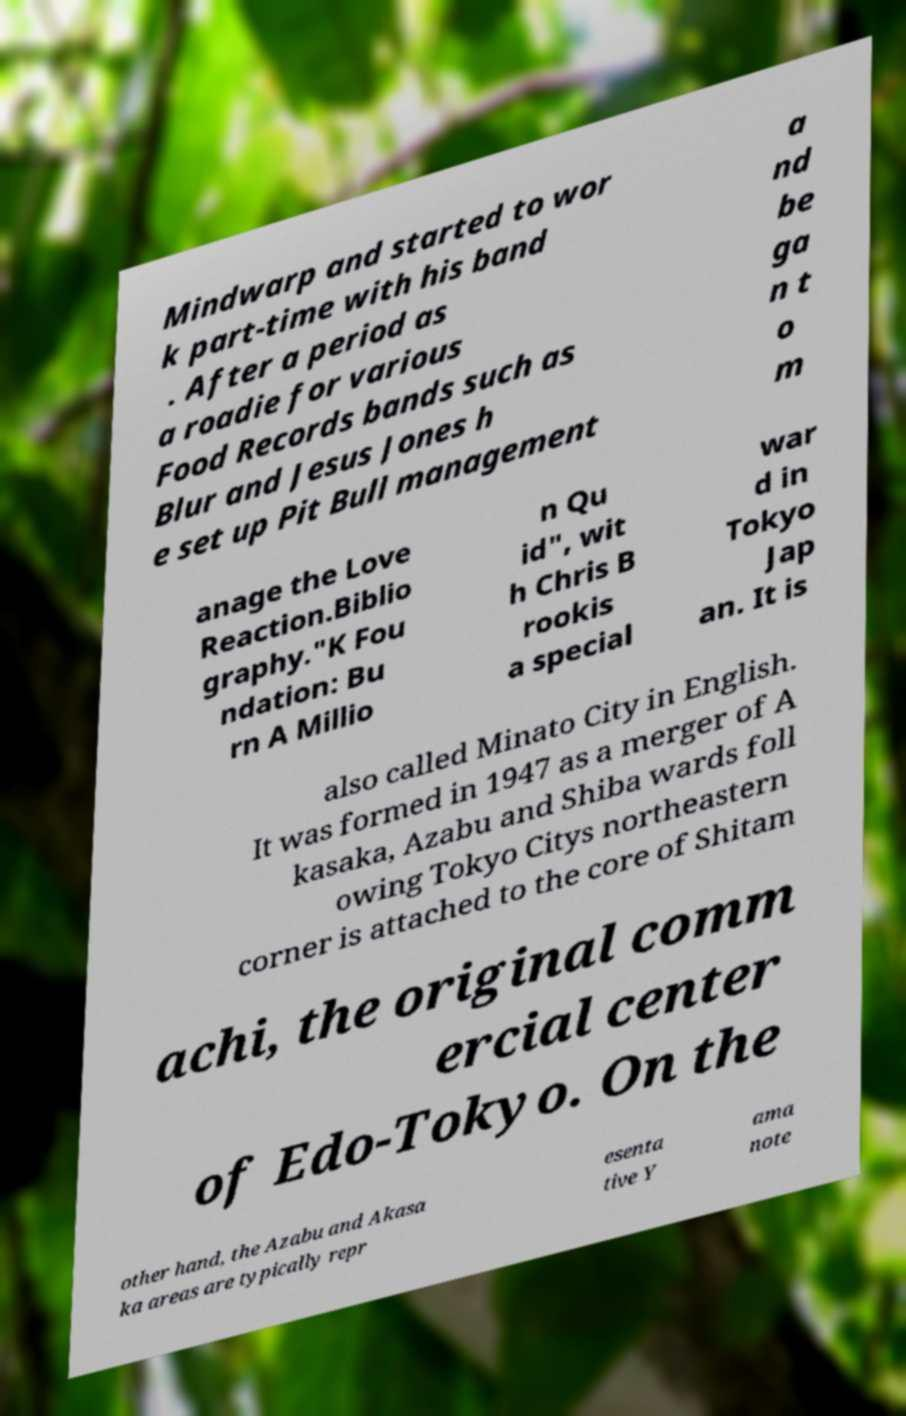What messages or text are displayed in this image? I need them in a readable, typed format. Mindwarp and started to wor k part-time with his band . After a period as a roadie for various Food Records bands such as Blur and Jesus Jones h e set up Pit Bull management a nd be ga n t o m anage the Love Reaction.Biblio graphy."K Fou ndation: Bu rn A Millio n Qu id", wit h Chris B rookis a special war d in Tokyo Jap an. It is also called Minato City in English. It was formed in 1947 as a merger of A kasaka, Azabu and Shiba wards foll owing Tokyo Citys northeastern corner is attached to the core of Shitam achi, the original comm ercial center of Edo-Tokyo. On the other hand, the Azabu and Akasa ka areas are typically repr esenta tive Y ama note 